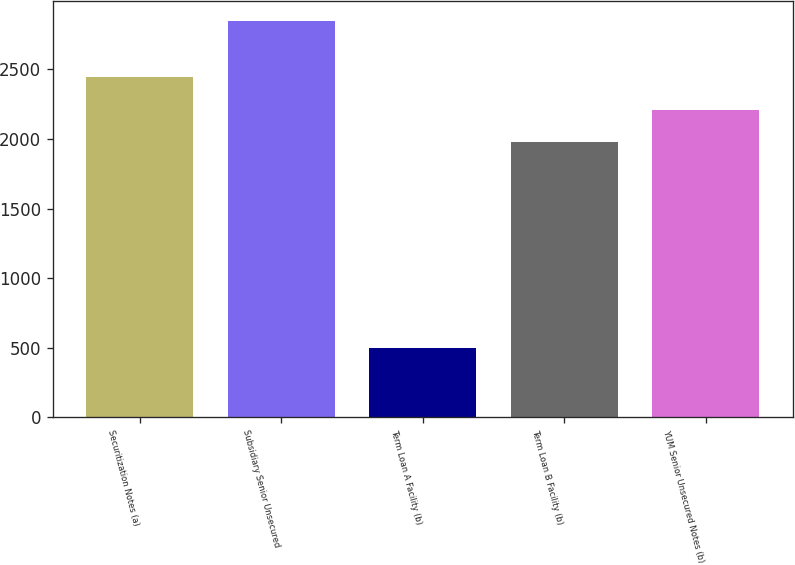Convert chart to OTSL. <chart><loc_0><loc_0><loc_500><loc_500><bar_chart><fcel>Securitization Notes (a)<fcel>Subsidiary Senior Unsecured<fcel>Term Loan A Facility (b)<fcel>Term Loan B Facility (b)<fcel>YUM Senior Unsecured Notes (b)<nl><fcel>2445<fcel>2850<fcel>500<fcel>1975<fcel>2210<nl></chart> 